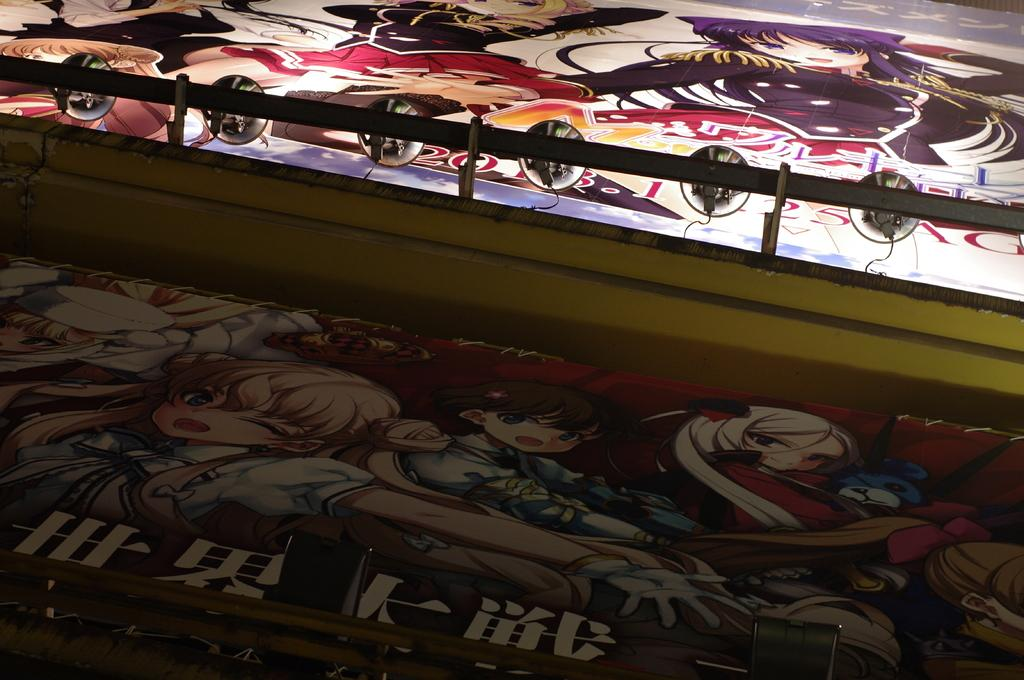What type of artwork is depicted in the image? There are paintings of cartoons in the image. Where is the maid in the image? There is no maid present in the image; it only features paintings of cartoons. 